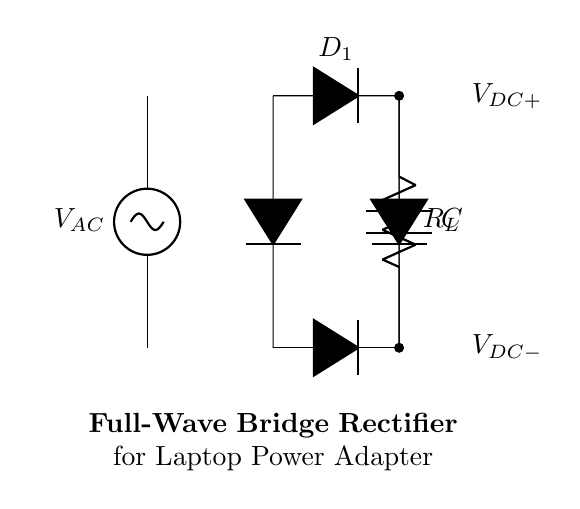What type of rectifier is shown in the diagram? The diagram illustrates a full-wave bridge rectifier, which is designed to convert alternating current (AC) to direct current (DC) by utilizing four diodes arranged in a bridge configuration.
Answer: full-wave bridge rectifier How many diodes are in the circuit? The circuit contains four diodes (D1, D2, D3, and D4) that work together to rectify both halves of the AC input waveform.
Answer: four What component is used to smooth the output voltage? The capacitor (C) is used in the circuit to filter the rectified voltage, providing a smoother DC output by charging and discharging as the voltage fluctuates.
Answer: capacitor What is the purpose of the load resistor in this circuit? The load resistor (R_L) allows the circuit to deliver power to a connected load, providing a path for the current to flow while also serving to limit the current based on the voltage across it.
Answer: load resistor What is the output voltage configuration? The output voltage in this bridge rectifier circuit is presented as V_DC+ and V_DC-, where V_DC+ represents the positive output and V_DC- indicates the negative output relative to ground.
Answer: V_DC+ and V_DC- Which component prevents reverse current flow? The diode components prevent reverse current flow during the negative half of the AC cycle, ensuring that current only flows in one direction through the load to maintain a unidirectional output.
Answer: diodes What happens to the output voltage when the load resistance increases? When the load resistance increases, the output voltage tends to rise due to reduced current draw from the circuit as per Ohm's law; less load current results in less voltage drop across the load.
Answer: output voltage rises 